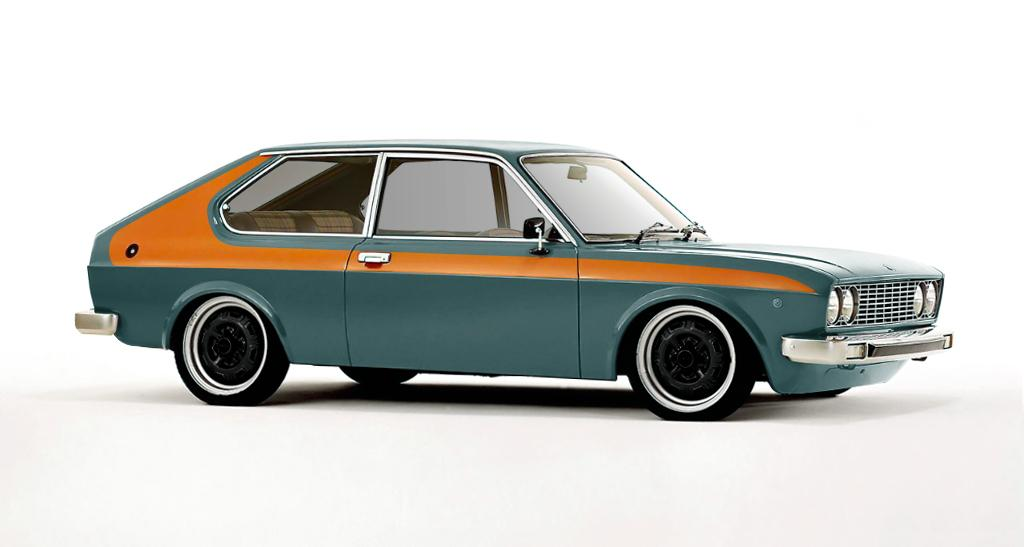What is the main subject of the picture? The main subject of the picture is a car. What color is the surface on which the car is placed? The car is on a white color surface. What is the color of the car? The car is green in color. What is the color of the background in the image? The background of the image is white in color. Can you tell me how many zebras are sitting on the cushion in the image? There are no zebras or cushions present in the image; it features a green car on a white surface with a white background. 